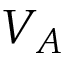Convert formula to latex. <formula><loc_0><loc_0><loc_500><loc_500>V _ { A }</formula> 